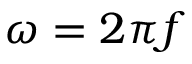<formula> <loc_0><loc_0><loc_500><loc_500>\omega = 2 \pi f</formula> 